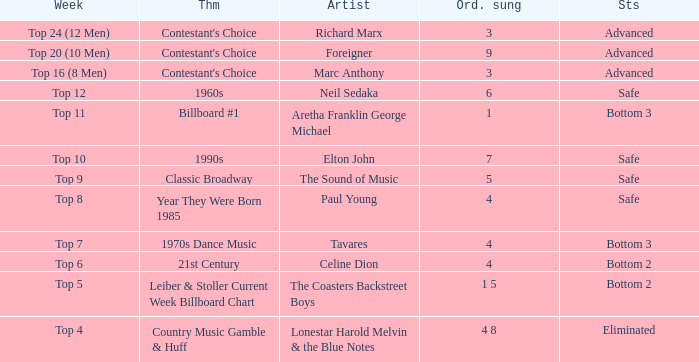What is the status when the artist is Neil Sedaka? Safe. 